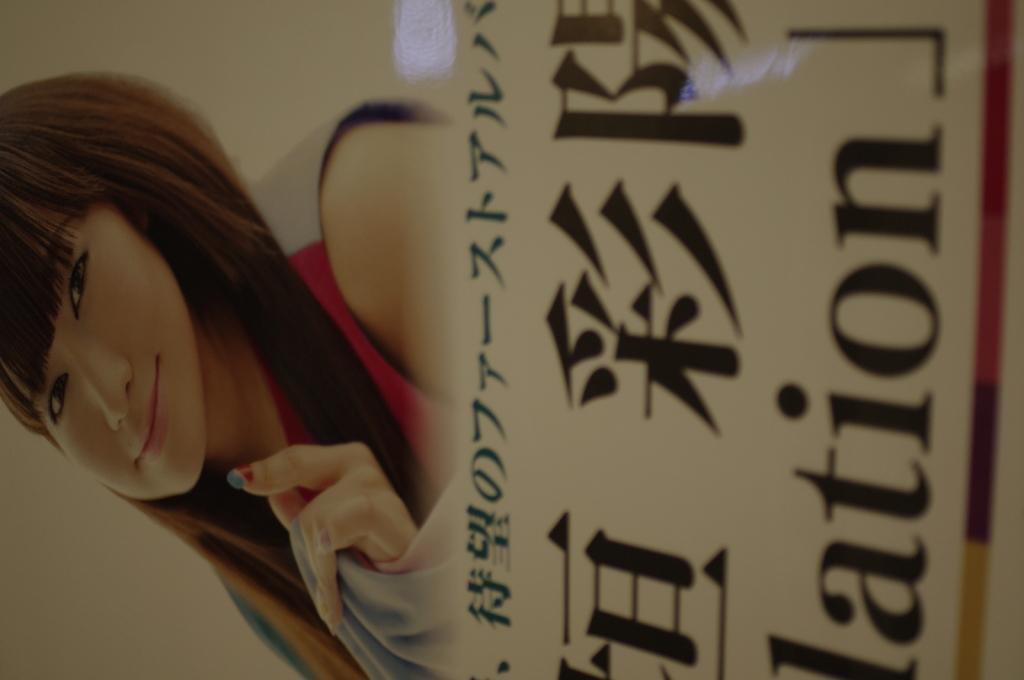How would you summarize this image in a sentence or two? In this picture there is a poster. On the poster there is a picture of a woman and there is text. 